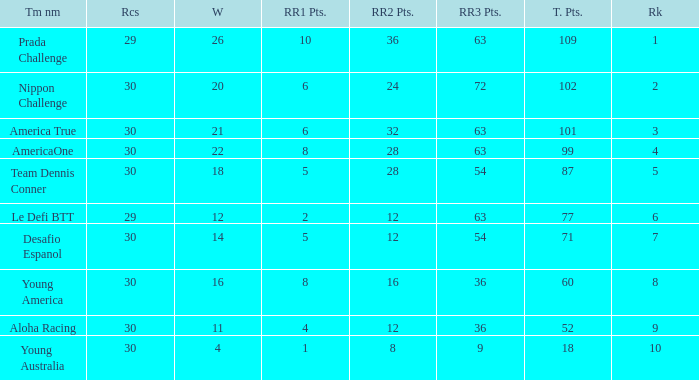Name the min total pts for team dennis conner 87.0. 